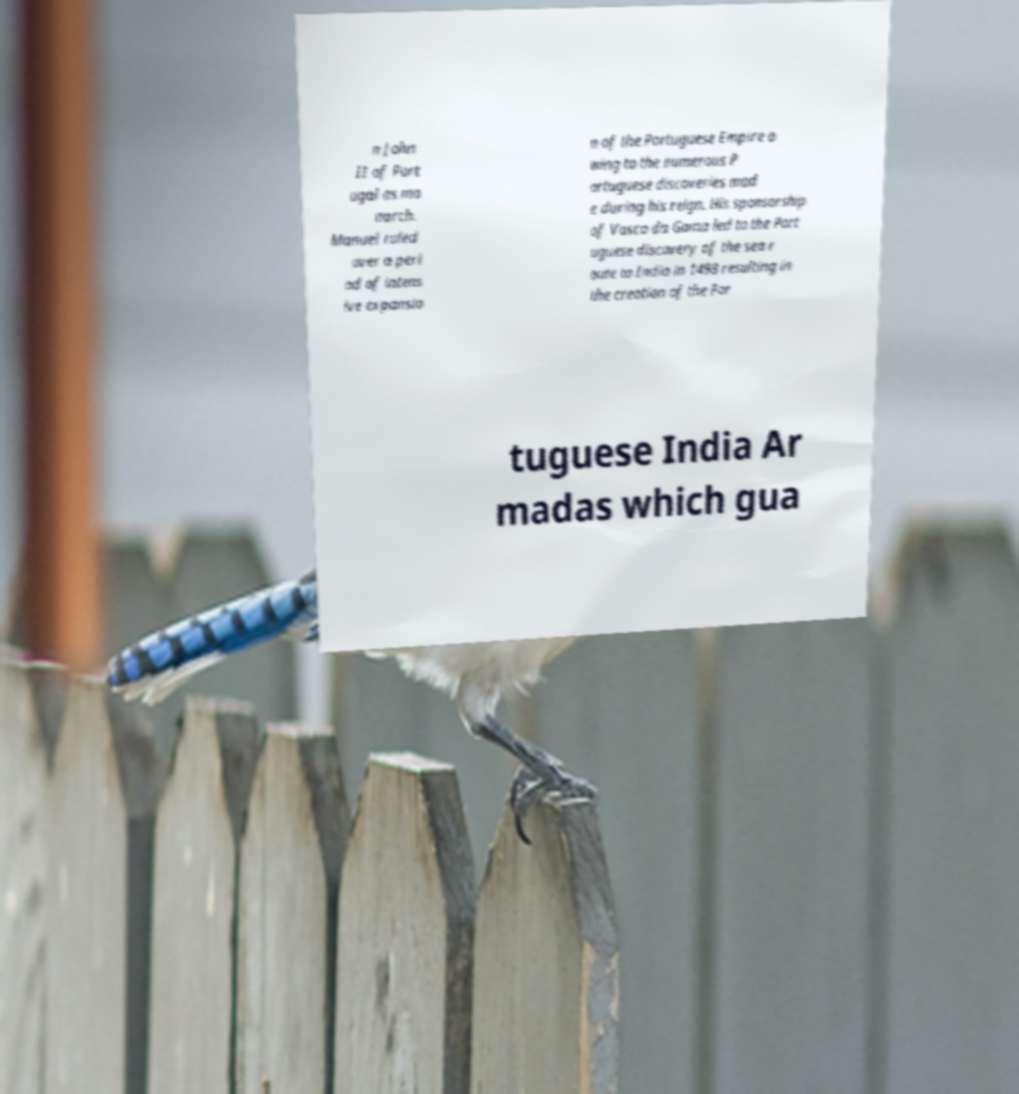Could you extract and type out the text from this image? n John II of Port ugal as mo narch. Manuel ruled over a peri od of intens ive expansio n of the Portuguese Empire o wing to the numerous P ortuguese discoveries mad e during his reign. His sponsorship of Vasco da Gama led to the Port uguese discovery of the sea r oute to India in 1498 resulting in the creation of the Por tuguese India Ar madas which gua 